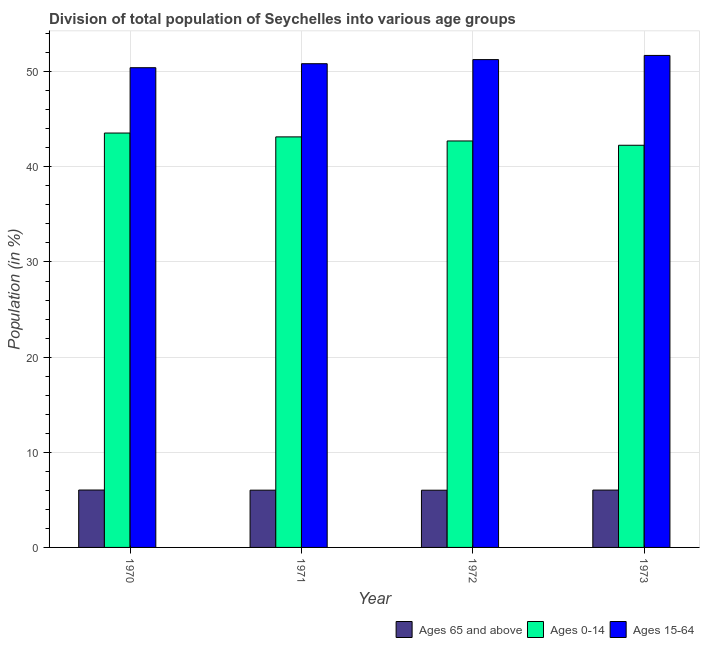How many different coloured bars are there?
Offer a very short reply. 3. Are the number of bars on each tick of the X-axis equal?
Ensure brevity in your answer.  Yes. In how many cases, is the number of bars for a given year not equal to the number of legend labels?
Ensure brevity in your answer.  0. What is the percentage of population within the age-group of 65 and above in 1972?
Keep it short and to the point. 6.01. Across all years, what is the maximum percentage of population within the age-group 0-14?
Keep it short and to the point. 43.55. Across all years, what is the minimum percentage of population within the age-group of 65 and above?
Provide a short and direct response. 6.01. In which year was the percentage of population within the age-group 0-14 minimum?
Your answer should be compact. 1973. What is the total percentage of population within the age-group 0-14 in the graph?
Provide a short and direct response. 171.68. What is the difference between the percentage of population within the age-group of 65 and above in 1970 and that in 1971?
Ensure brevity in your answer.  0.01. What is the difference between the percentage of population within the age-group 15-64 in 1973 and the percentage of population within the age-group of 65 and above in 1971?
Offer a very short reply. 0.87. What is the average percentage of population within the age-group 15-64 per year?
Keep it short and to the point. 51.06. In the year 1971, what is the difference between the percentage of population within the age-group 15-64 and percentage of population within the age-group of 65 and above?
Ensure brevity in your answer.  0. In how many years, is the percentage of population within the age-group 0-14 greater than 42 %?
Ensure brevity in your answer.  4. What is the ratio of the percentage of population within the age-group 0-14 in 1971 to that in 1972?
Your response must be concise. 1.01. Is the percentage of population within the age-group 15-64 in 1970 less than that in 1973?
Your response must be concise. Yes. Is the difference between the percentage of population within the age-group 15-64 in 1971 and 1973 greater than the difference between the percentage of population within the age-group of 65 and above in 1971 and 1973?
Your response must be concise. No. What is the difference between the highest and the second highest percentage of population within the age-group of 65 and above?
Give a very brief answer. 0.01. What is the difference between the highest and the lowest percentage of population within the age-group 15-64?
Ensure brevity in your answer.  1.29. Is the sum of the percentage of population within the age-group 15-64 in 1972 and 1973 greater than the maximum percentage of population within the age-group 0-14 across all years?
Offer a terse response. Yes. What does the 2nd bar from the left in 1973 represents?
Provide a succinct answer. Ages 0-14. What does the 3rd bar from the right in 1973 represents?
Offer a terse response. Ages 65 and above. How many bars are there?
Provide a short and direct response. 12. How many years are there in the graph?
Offer a very short reply. 4. Where does the legend appear in the graph?
Provide a succinct answer. Bottom right. What is the title of the graph?
Ensure brevity in your answer.  Division of total population of Seychelles into various age groups
. Does "Communicable diseases" appear as one of the legend labels in the graph?
Offer a very short reply. No. What is the label or title of the X-axis?
Your response must be concise. Year. What is the Population (in %) in Ages 65 and above in 1970?
Your response must be concise. 6.03. What is the Population (in %) of Ages 0-14 in 1970?
Offer a terse response. 43.55. What is the Population (in %) of Ages 15-64 in 1970?
Give a very brief answer. 50.42. What is the Population (in %) in Ages 65 and above in 1971?
Your answer should be compact. 6.02. What is the Population (in %) of Ages 0-14 in 1971?
Ensure brevity in your answer.  43.15. What is the Population (in %) in Ages 15-64 in 1971?
Offer a terse response. 50.84. What is the Population (in %) of Ages 65 and above in 1972?
Make the answer very short. 6.01. What is the Population (in %) in Ages 0-14 in 1972?
Provide a succinct answer. 42.72. What is the Population (in %) of Ages 15-64 in 1972?
Offer a terse response. 51.27. What is the Population (in %) of Ages 65 and above in 1973?
Provide a succinct answer. 6.03. What is the Population (in %) of Ages 0-14 in 1973?
Provide a succinct answer. 42.27. What is the Population (in %) of Ages 15-64 in 1973?
Your response must be concise. 51.71. Across all years, what is the maximum Population (in %) in Ages 65 and above?
Make the answer very short. 6.03. Across all years, what is the maximum Population (in %) of Ages 0-14?
Keep it short and to the point. 43.55. Across all years, what is the maximum Population (in %) of Ages 15-64?
Provide a short and direct response. 51.71. Across all years, what is the minimum Population (in %) of Ages 65 and above?
Make the answer very short. 6.01. Across all years, what is the minimum Population (in %) of Ages 0-14?
Your response must be concise. 42.27. Across all years, what is the minimum Population (in %) in Ages 15-64?
Your answer should be very brief. 50.42. What is the total Population (in %) in Ages 65 and above in the graph?
Offer a terse response. 24.09. What is the total Population (in %) in Ages 0-14 in the graph?
Your answer should be compact. 171.68. What is the total Population (in %) of Ages 15-64 in the graph?
Provide a succinct answer. 204.23. What is the difference between the Population (in %) of Ages 65 and above in 1970 and that in 1971?
Your answer should be very brief. 0.01. What is the difference between the Population (in %) in Ages 0-14 in 1970 and that in 1971?
Your response must be concise. 0.4. What is the difference between the Population (in %) of Ages 15-64 in 1970 and that in 1971?
Offer a very short reply. -0.42. What is the difference between the Population (in %) in Ages 65 and above in 1970 and that in 1972?
Your answer should be compact. 0.02. What is the difference between the Population (in %) in Ages 0-14 in 1970 and that in 1972?
Provide a succinct answer. 0.83. What is the difference between the Population (in %) in Ages 15-64 in 1970 and that in 1972?
Offer a terse response. -0.85. What is the difference between the Population (in %) of Ages 65 and above in 1970 and that in 1973?
Provide a succinct answer. 0.01. What is the difference between the Population (in %) of Ages 0-14 in 1970 and that in 1973?
Your answer should be compact. 1.28. What is the difference between the Population (in %) in Ages 15-64 in 1970 and that in 1973?
Offer a very short reply. -1.29. What is the difference between the Population (in %) of Ages 65 and above in 1971 and that in 1972?
Provide a short and direct response. 0. What is the difference between the Population (in %) of Ages 0-14 in 1971 and that in 1972?
Give a very brief answer. 0.43. What is the difference between the Population (in %) of Ages 15-64 in 1971 and that in 1972?
Provide a succinct answer. -0.43. What is the difference between the Population (in %) in Ages 65 and above in 1971 and that in 1973?
Make the answer very short. -0.01. What is the difference between the Population (in %) of Ages 0-14 in 1971 and that in 1973?
Your response must be concise. 0.88. What is the difference between the Population (in %) in Ages 15-64 in 1971 and that in 1973?
Offer a terse response. -0.87. What is the difference between the Population (in %) in Ages 65 and above in 1972 and that in 1973?
Ensure brevity in your answer.  -0.01. What is the difference between the Population (in %) in Ages 0-14 in 1972 and that in 1973?
Your response must be concise. 0.45. What is the difference between the Population (in %) in Ages 15-64 in 1972 and that in 1973?
Your answer should be very brief. -0.44. What is the difference between the Population (in %) in Ages 65 and above in 1970 and the Population (in %) in Ages 0-14 in 1971?
Provide a short and direct response. -37.11. What is the difference between the Population (in %) in Ages 65 and above in 1970 and the Population (in %) in Ages 15-64 in 1971?
Offer a very short reply. -44.8. What is the difference between the Population (in %) in Ages 0-14 in 1970 and the Population (in %) in Ages 15-64 in 1971?
Make the answer very short. -7.29. What is the difference between the Population (in %) of Ages 65 and above in 1970 and the Population (in %) of Ages 0-14 in 1972?
Your response must be concise. -36.69. What is the difference between the Population (in %) in Ages 65 and above in 1970 and the Population (in %) in Ages 15-64 in 1972?
Give a very brief answer. -45.24. What is the difference between the Population (in %) in Ages 0-14 in 1970 and the Population (in %) in Ages 15-64 in 1972?
Provide a short and direct response. -7.72. What is the difference between the Population (in %) in Ages 65 and above in 1970 and the Population (in %) in Ages 0-14 in 1973?
Give a very brief answer. -36.23. What is the difference between the Population (in %) of Ages 65 and above in 1970 and the Population (in %) of Ages 15-64 in 1973?
Provide a short and direct response. -45.67. What is the difference between the Population (in %) in Ages 0-14 in 1970 and the Population (in %) in Ages 15-64 in 1973?
Keep it short and to the point. -8.16. What is the difference between the Population (in %) of Ages 65 and above in 1971 and the Population (in %) of Ages 0-14 in 1972?
Give a very brief answer. -36.7. What is the difference between the Population (in %) of Ages 65 and above in 1971 and the Population (in %) of Ages 15-64 in 1972?
Your response must be concise. -45.25. What is the difference between the Population (in %) of Ages 0-14 in 1971 and the Population (in %) of Ages 15-64 in 1972?
Keep it short and to the point. -8.12. What is the difference between the Population (in %) of Ages 65 and above in 1971 and the Population (in %) of Ages 0-14 in 1973?
Your response must be concise. -36.25. What is the difference between the Population (in %) in Ages 65 and above in 1971 and the Population (in %) in Ages 15-64 in 1973?
Offer a terse response. -45.69. What is the difference between the Population (in %) in Ages 0-14 in 1971 and the Population (in %) in Ages 15-64 in 1973?
Ensure brevity in your answer.  -8.56. What is the difference between the Population (in %) in Ages 65 and above in 1972 and the Population (in %) in Ages 0-14 in 1973?
Ensure brevity in your answer.  -36.25. What is the difference between the Population (in %) in Ages 65 and above in 1972 and the Population (in %) in Ages 15-64 in 1973?
Your answer should be very brief. -45.69. What is the difference between the Population (in %) of Ages 0-14 in 1972 and the Population (in %) of Ages 15-64 in 1973?
Offer a terse response. -8.99. What is the average Population (in %) of Ages 65 and above per year?
Provide a succinct answer. 6.02. What is the average Population (in %) in Ages 0-14 per year?
Offer a very short reply. 42.92. What is the average Population (in %) in Ages 15-64 per year?
Your response must be concise. 51.06. In the year 1970, what is the difference between the Population (in %) of Ages 65 and above and Population (in %) of Ages 0-14?
Give a very brief answer. -37.52. In the year 1970, what is the difference between the Population (in %) in Ages 65 and above and Population (in %) in Ages 15-64?
Provide a succinct answer. -44.38. In the year 1970, what is the difference between the Population (in %) in Ages 0-14 and Population (in %) in Ages 15-64?
Make the answer very short. -6.87. In the year 1971, what is the difference between the Population (in %) in Ages 65 and above and Population (in %) in Ages 0-14?
Keep it short and to the point. -37.13. In the year 1971, what is the difference between the Population (in %) in Ages 65 and above and Population (in %) in Ages 15-64?
Keep it short and to the point. -44.82. In the year 1971, what is the difference between the Population (in %) in Ages 0-14 and Population (in %) in Ages 15-64?
Ensure brevity in your answer.  -7.69. In the year 1972, what is the difference between the Population (in %) in Ages 65 and above and Population (in %) in Ages 0-14?
Ensure brevity in your answer.  -36.71. In the year 1972, what is the difference between the Population (in %) of Ages 65 and above and Population (in %) of Ages 15-64?
Ensure brevity in your answer.  -45.25. In the year 1972, what is the difference between the Population (in %) of Ages 0-14 and Population (in %) of Ages 15-64?
Make the answer very short. -8.55. In the year 1973, what is the difference between the Population (in %) in Ages 65 and above and Population (in %) in Ages 0-14?
Your answer should be very brief. -36.24. In the year 1973, what is the difference between the Population (in %) of Ages 65 and above and Population (in %) of Ages 15-64?
Provide a succinct answer. -45.68. In the year 1973, what is the difference between the Population (in %) in Ages 0-14 and Population (in %) in Ages 15-64?
Your response must be concise. -9.44. What is the ratio of the Population (in %) in Ages 0-14 in 1970 to that in 1971?
Provide a short and direct response. 1.01. What is the ratio of the Population (in %) of Ages 15-64 in 1970 to that in 1971?
Make the answer very short. 0.99. What is the ratio of the Population (in %) in Ages 0-14 in 1970 to that in 1972?
Keep it short and to the point. 1.02. What is the ratio of the Population (in %) in Ages 15-64 in 1970 to that in 1972?
Your answer should be compact. 0.98. What is the ratio of the Population (in %) of Ages 0-14 in 1970 to that in 1973?
Your response must be concise. 1.03. What is the ratio of the Population (in %) of Ages 0-14 in 1971 to that in 1972?
Give a very brief answer. 1.01. What is the ratio of the Population (in %) in Ages 0-14 in 1971 to that in 1973?
Your answer should be compact. 1.02. What is the ratio of the Population (in %) in Ages 15-64 in 1971 to that in 1973?
Give a very brief answer. 0.98. What is the ratio of the Population (in %) of Ages 65 and above in 1972 to that in 1973?
Your response must be concise. 1. What is the ratio of the Population (in %) of Ages 0-14 in 1972 to that in 1973?
Offer a very short reply. 1.01. What is the difference between the highest and the second highest Population (in %) of Ages 65 and above?
Keep it short and to the point. 0.01. What is the difference between the highest and the second highest Population (in %) in Ages 0-14?
Provide a short and direct response. 0.4. What is the difference between the highest and the second highest Population (in %) of Ages 15-64?
Your response must be concise. 0.44. What is the difference between the highest and the lowest Population (in %) in Ages 65 and above?
Keep it short and to the point. 0.02. What is the difference between the highest and the lowest Population (in %) in Ages 0-14?
Make the answer very short. 1.28. What is the difference between the highest and the lowest Population (in %) of Ages 15-64?
Provide a short and direct response. 1.29. 